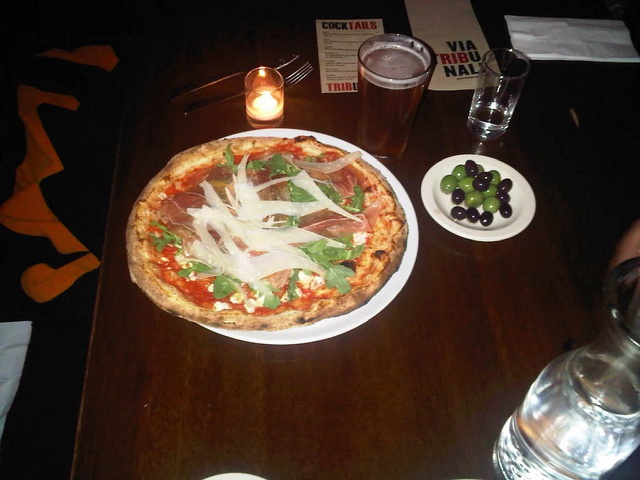Describe the objects in this image and their specific colors. I can see dining table in black, maroon, ivory, and gray tones, pizza in black, tan, beige, and brown tones, bottle in black, white, gray, and darkgray tones, cup in black, gray, and maroon tones, and cup in black and gray tones in this image. 